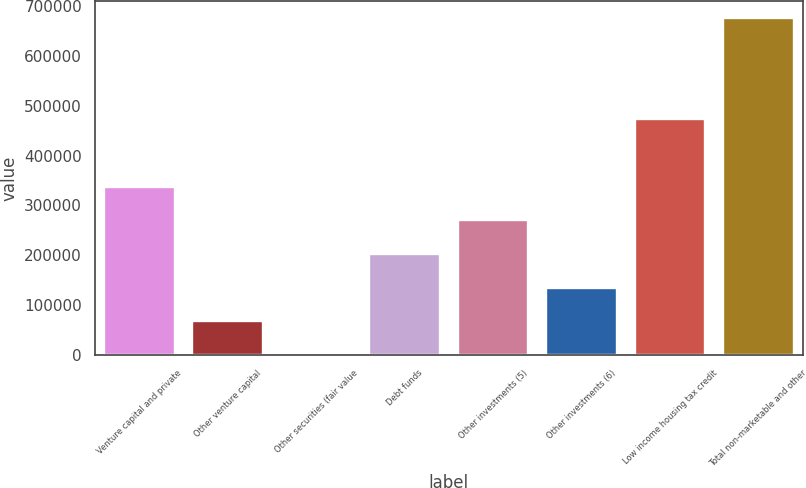<chart> <loc_0><loc_0><loc_500><loc_500><bar_chart><fcel>Venture capital and private<fcel>Other venture capital<fcel>Other securities (fair value<fcel>Debt funds<fcel>Other investments (5)<fcel>Other investments (6)<fcel>Low income housing tax credit<fcel>Total non-marketable and other<nl><fcel>337747<fcel>67987.8<fcel>548<fcel>202867<fcel>270307<fcel>135428<fcel>472627<fcel>674946<nl></chart> 